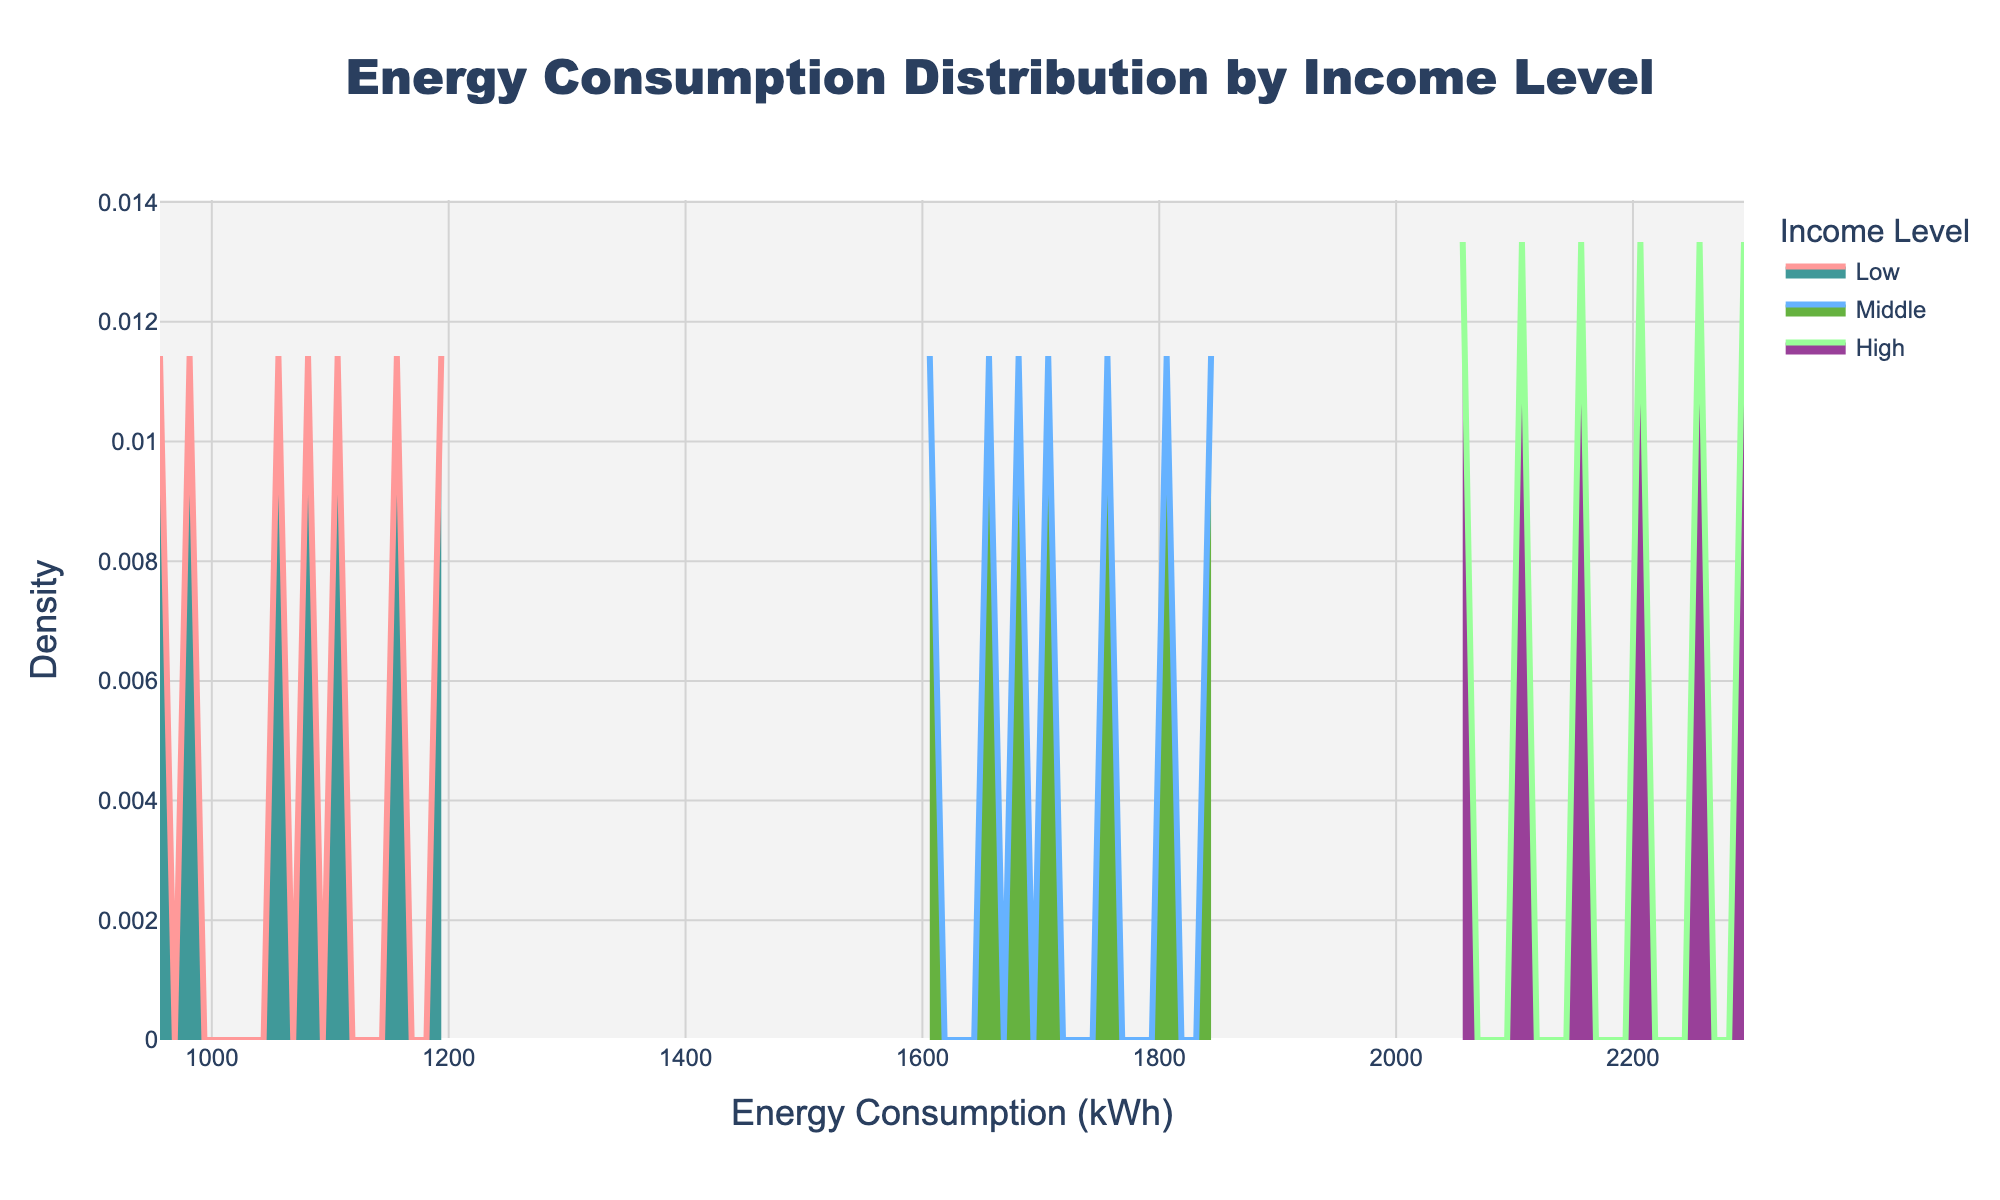What is the main title of the plot? The main title is prominently displayed at the top of the plot and includes the summary of the information being shown.
Answer: Energy Consumption Distribution by Income Level What are the colors used for the different income levels in the plot? The colors for each income level are distinguishable through the color fill and line colors for the density plots.
Answer: Low: Light Red, Middle: Light Blue, High: Light Green What is the range of energy consumption in kWh shown on the x-axis? The x-axis shows the amount of energy consumption in kilowatt-hours (kWh) ranging from the minimum to the maximum value shown on the x-axis.
Answer: 900 - 2400 kWh Which income level shows the highest peak in energy consumption density? The density peak is the highest part of the curve for each income level. By analyzing the density plot, the income level with the highest peak can be determined.
Answer: Middle At approximately what energy consumption (kWh) does the 'Low' income level's density peak occur? The peak of the 'Low' income level can be identified by finding the highest point along the density curve for 'Low' income.
Answer: Around 1100 kWh Which income level has the broadest distribution of energy consumption? The broadness of the distribution can be seen by the spread of the density curve along the x-axis for different income levels.
Answer: High How does the peak density of the 'Middle' income level compare to the 'High' income level? By comparing the height of the peaks of the density curves for 'Middle' and 'High' income levels, we can see which one is taller.
Answer: The 'Middle' income level has a higher peak density than 'High' What can be inferred about the energy consumption of high-income households compared to low-income households? This involves comparing the density distributions of high-income and low-income households across energy consumption values. The density plot indicates the spread and central tendency for both categories.
Answer: High-income households tend to have higher energy consumption Which income level shows the smallest variation in energy consumption based on the density plot? The smallest variation is indicated by the narrowest and most concentrated part of the density plot. By finding which income level curve is least spread out, we can determine this.
Answer: Low 